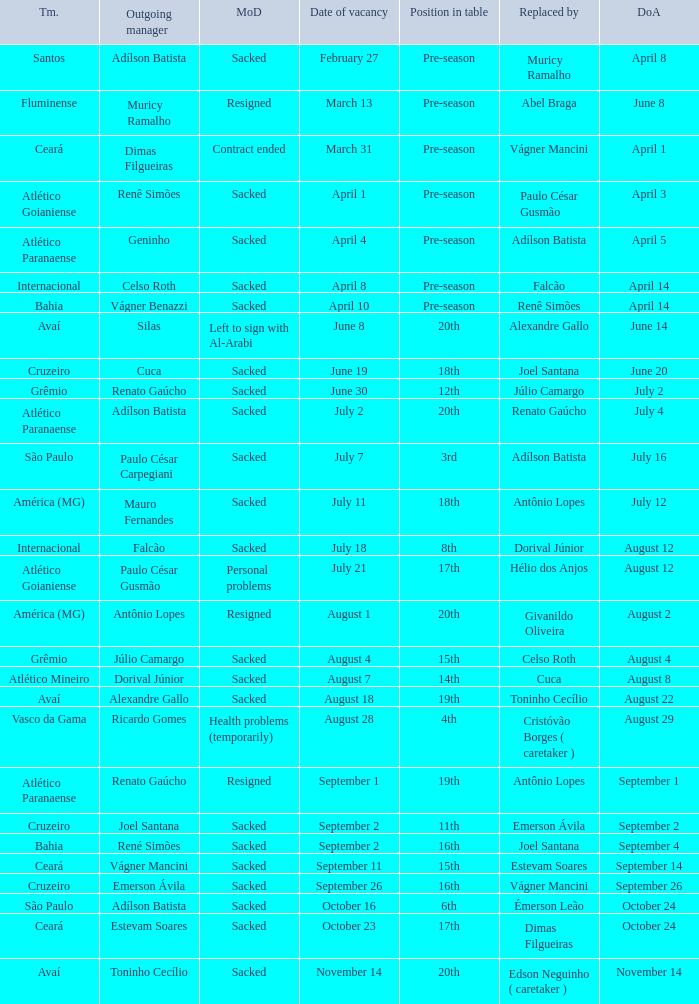Who was the new Santos manager? Muricy Ramalho. 